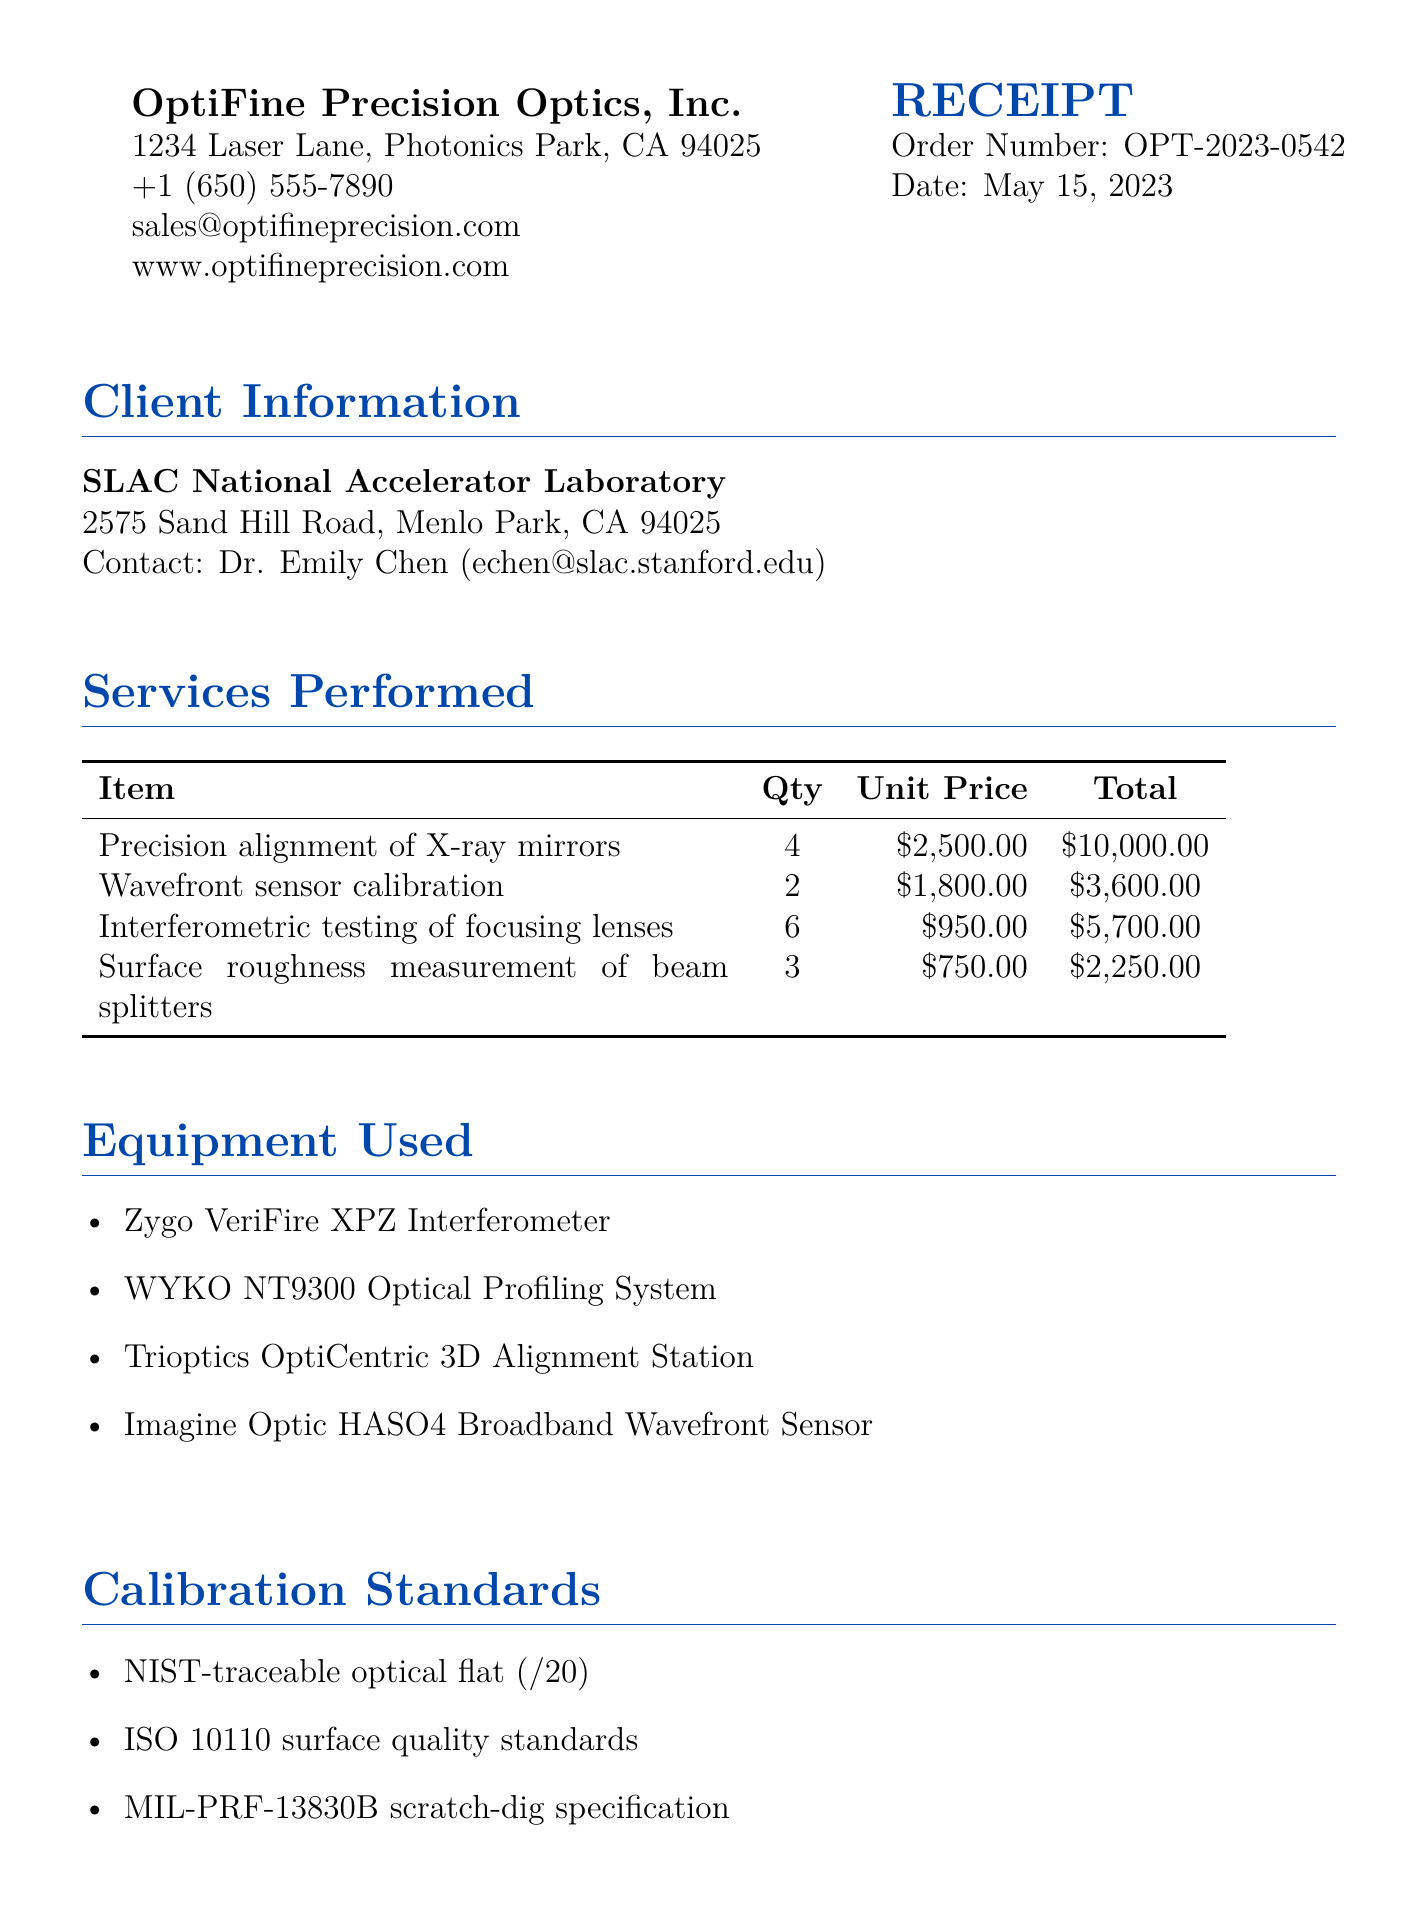What is the order number? The order number is specified in the document under Order Details.
Answer: OPT-2023-0542 Who is the contact person for the client? The contact person is mentioned under Client Information.
Answer: Dr. Emily Chen What is the tax amount? The tax amount is calculated based on the subtotal and tax rate in the Payment Information section.
Answer: $1,939.50 How many X-ray mirrors were aligned? The quantity of X-ray mirrors aligned is mentioned in the Services Performed section.
Answer: 4 What is the total due amount? The total due amount is the sum of the subtotal and tax amount in the Payment Information.
Answer: $23,489.50 Which equipment was used for the calibration? The equipment used is listed in the Equipment Used section of the document.
Answer: Zygo VeriFire XPZ Interferometer What is the warranty period on the services? The warranty period is specified in the Quality Assurance section.
Answer: 90-day What class of cleanroom was used for the calibrations? The class of cleanroom is mentioned in the Additional Notes section.
Answer: ISO Class 5 What type of certification does the company hold? The type of certification is stated in the Quality Assurance section.
Answer: ISO 9001:2015 certified 